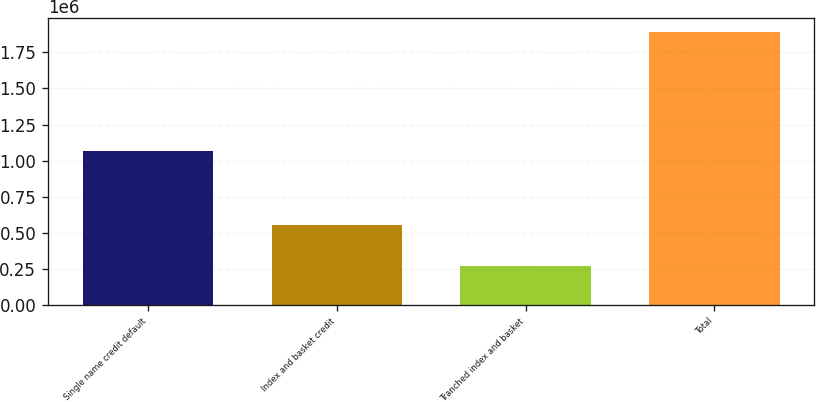<chart> <loc_0><loc_0><loc_500><loc_500><bar_chart><fcel>Single name credit default<fcel>Index and basket credit<fcel>Tranched index and basket<fcel>Total<nl><fcel>1.06947e+06<fcel>551630<fcel>272088<fcel>1.89319e+06<nl></chart> 